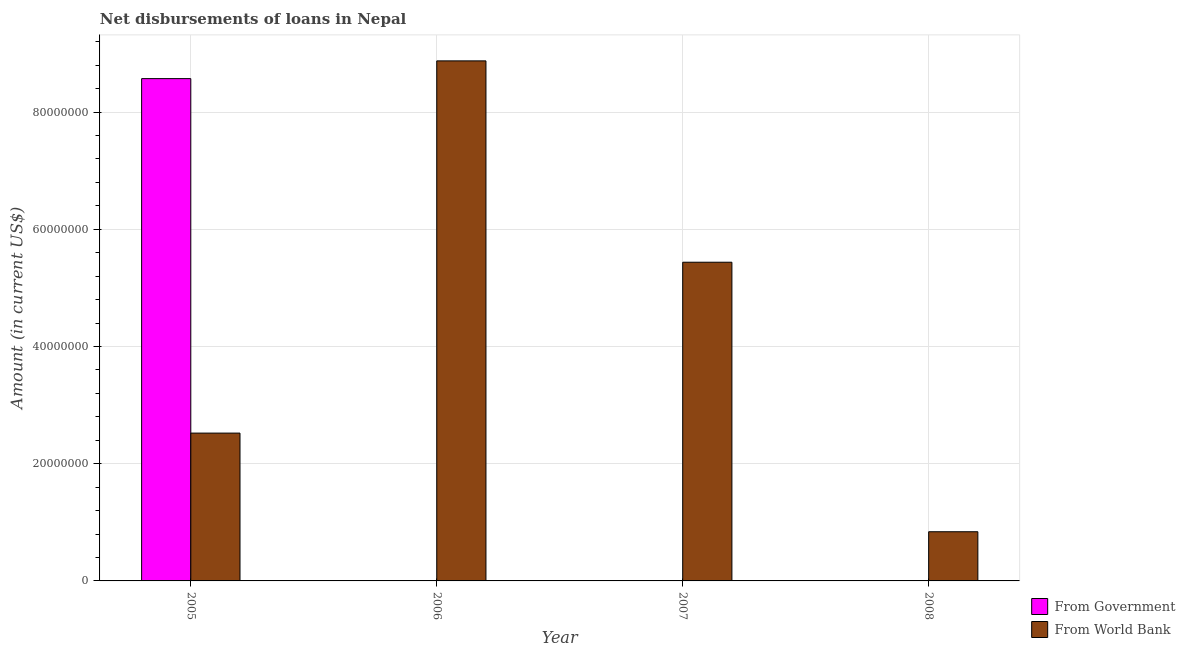Are the number of bars per tick equal to the number of legend labels?
Your answer should be compact. No. Are the number of bars on each tick of the X-axis equal?
Offer a very short reply. No. How many bars are there on the 1st tick from the left?
Provide a succinct answer. 2. What is the net disbursements of loan from government in 2005?
Offer a terse response. 8.57e+07. Across all years, what is the maximum net disbursements of loan from government?
Your response must be concise. 8.57e+07. What is the total net disbursements of loan from world bank in the graph?
Offer a very short reply. 1.77e+08. What is the difference between the net disbursements of loan from world bank in 2005 and that in 2007?
Provide a short and direct response. -2.92e+07. What is the difference between the net disbursements of loan from world bank in 2008 and the net disbursements of loan from government in 2007?
Give a very brief answer. -4.60e+07. What is the average net disbursements of loan from world bank per year?
Keep it short and to the point. 4.42e+07. In the year 2007, what is the difference between the net disbursements of loan from world bank and net disbursements of loan from government?
Your answer should be compact. 0. In how many years, is the net disbursements of loan from government greater than 76000000 US$?
Your answer should be very brief. 1. What is the ratio of the net disbursements of loan from world bank in 2005 to that in 2008?
Ensure brevity in your answer.  3.01. What is the difference between the highest and the second highest net disbursements of loan from world bank?
Offer a terse response. 3.44e+07. What is the difference between the highest and the lowest net disbursements of loan from government?
Provide a succinct answer. 8.57e+07. Is the sum of the net disbursements of loan from world bank in 2006 and 2007 greater than the maximum net disbursements of loan from government across all years?
Give a very brief answer. Yes. Are all the bars in the graph horizontal?
Your answer should be very brief. No. How many years are there in the graph?
Your answer should be compact. 4. Does the graph contain grids?
Provide a succinct answer. Yes. Where does the legend appear in the graph?
Give a very brief answer. Bottom right. How many legend labels are there?
Your answer should be very brief. 2. How are the legend labels stacked?
Give a very brief answer. Vertical. What is the title of the graph?
Your answer should be very brief. Net disbursements of loans in Nepal. Does "Female entrants" appear as one of the legend labels in the graph?
Your response must be concise. No. What is the Amount (in current US$) of From Government in 2005?
Your response must be concise. 8.57e+07. What is the Amount (in current US$) in From World Bank in 2005?
Offer a terse response. 2.52e+07. What is the Amount (in current US$) in From Government in 2006?
Offer a terse response. 0. What is the Amount (in current US$) of From World Bank in 2006?
Provide a short and direct response. 8.87e+07. What is the Amount (in current US$) of From Government in 2007?
Make the answer very short. 0. What is the Amount (in current US$) of From World Bank in 2007?
Ensure brevity in your answer.  5.44e+07. What is the Amount (in current US$) of From Government in 2008?
Your answer should be very brief. 0. What is the Amount (in current US$) of From World Bank in 2008?
Your answer should be compact. 8.39e+06. Across all years, what is the maximum Amount (in current US$) in From Government?
Your answer should be very brief. 8.57e+07. Across all years, what is the maximum Amount (in current US$) in From World Bank?
Provide a succinct answer. 8.87e+07. Across all years, what is the minimum Amount (in current US$) of From Government?
Your answer should be very brief. 0. Across all years, what is the minimum Amount (in current US$) in From World Bank?
Keep it short and to the point. 8.39e+06. What is the total Amount (in current US$) of From Government in the graph?
Make the answer very short. 8.57e+07. What is the total Amount (in current US$) in From World Bank in the graph?
Your response must be concise. 1.77e+08. What is the difference between the Amount (in current US$) in From World Bank in 2005 and that in 2006?
Your answer should be very brief. -6.35e+07. What is the difference between the Amount (in current US$) in From World Bank in 2005 and that in 2007?
Make the answer very short. -2.92e+07. What is the difference between the Amount (in current US$) of From World Bank in 2005 and that in 2008?
Your answer should be very brief. 1.68e+07. What is the difference between the Amount (in current US$) in From World Bank in 2006 and that in 2007?
Your answer should be very brief. 3.44e+07. What is the difference between the Amount (in current US$) in From World Bank in 2006 and that in 2008?
Provide a succinct answer. 8.04e+07. What is the difference between the Amount (in current US$) of From World Bank in 2007 and that in 2008?
Your answer should be compact. 4.60e+07. What is the difference between the Amount (in current US$) of From Government in 2005 and the Amount (in current US$) of From World Bank in 2006?
Your response must be concise. -3.03e+06. What is the difference between the Amount (in current US$) in From Government in 2005 and the Amount (in current US$) in From World Bank in 2007?
Keep it short and to the point. 3.13e+07. What is the difference between the Amount (in current US$) of From Government in 2005 and the Amount (in current US$) of From World Bank in 2008?
Your answer should be compact. 7.73e+07. What is the average Amount (in current US$) of From Government per year?
Offer a terse response. 2.14e+07. What is the average Amount (in current US$) in From World Bank per year?
Keep it short and to the point. 4.42e+07. In the year 2005, what is the difference between the Amount (in current US$) of From Government and Amount (in current US$) of From World Bank?
Offer a very short reply. 6.05e+07. What is the ratio of the Amount (in current US$) in From World Bank in 2005 to that in 2006?
Give a very brief answer. 0.28. What is the ratio of the Amount (in current US$) of From World Bank in 2005 to that in 2007?
Offer a very short reply. 0.46. What is the ratio of the Amount (in current US$) of From World Bank in 2005 to that in 2008?
Make the answer very short. 3.01. What is the ratio of the Amount (in current US$) in From World Bank in 2006 to that in 2007?
Your answer should be very brief. 1.63. What is the ratio of the Amount (in current US$) in From World Bank in 2006 to that in 2008?
Offer a terse response. 10.58. What is the ratio of the Amount (in current US$) of From World Bank in 2007 to that in 2008?
Give a very brief answer. 6.48. What is the difference between the highest and the second highest Amount (in current US$) of From World Bank?
Keep it short and to the point. 3.44e+07. What is the difference between the highest and the lowest Amount (in current US$) of From Government?
Make the answer very short. 8.57e+07. What is the difference between the highest and the lowest Amount (in current US$) in From World Bank?
Your answer should be compact. 8.04e+07. 